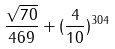<formula> <loc_0><loc_0><loc_500><loc_500>\frac { \sqrt { 7 0 } } { 4 6 9 } + ( \frac { 4 } { 1 0 } ) ^ { 3 0 4 }</formula> 